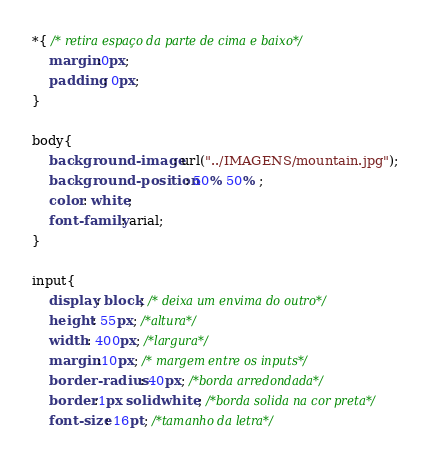Convert code to text. <code><loc_0><loc_0><loc_500><loc_500><_CSS_>*{ /* retira espaço da parte de cima e baixo*/
	margin:0px;
	padding: 0px;
} 

body{
	background-image: url("../IMAGENS/mountain.jpg");
	background-position: 50% 50% ;
	color: white;
	font-family: arial;
}

input{
	display: block; /* deixa um envima do outro*/
	height: 55px; /*altura*/
	width: 400px; /*largura*/
	margin:10px; /* margem entre os inputs*/
	border-radius: 40px; /*borda arredondada*/
	border:1px solid white; /*borda solida na cor preta*/
	font-size: 16pt; /*tamanho da letra*/</code> 